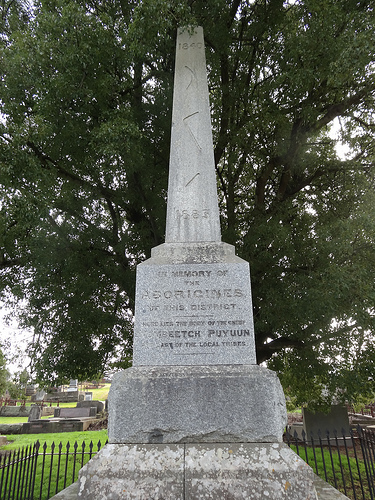<image>
Can you confirm if the fence is in front of the monument? No. The fence is not in front of the monument. The spatial positioning shows a different relationship between these objects. 